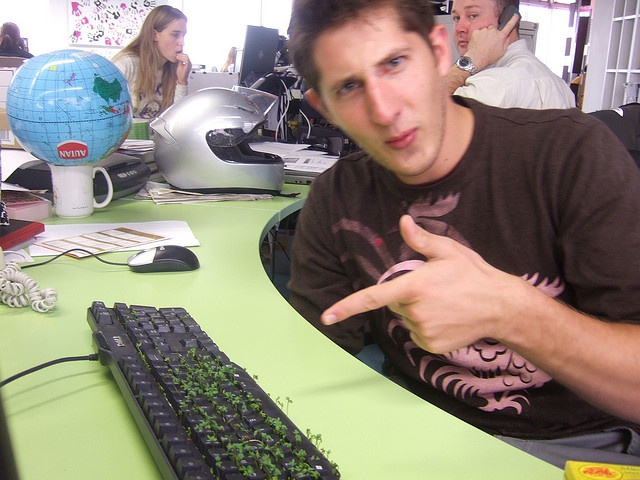Describe the objects in this image and their specific colors. I can see people in white, black, lightpink, and brown tones, keyboard in white, gray, black, and darkgreen tones, people in white, lightgray, lightpink, brown, and darkgray tones, people in white, gray, darkgray, and lightpink tones, and cup in white, lightgray, darkgray, black, and gray tones in this image. 